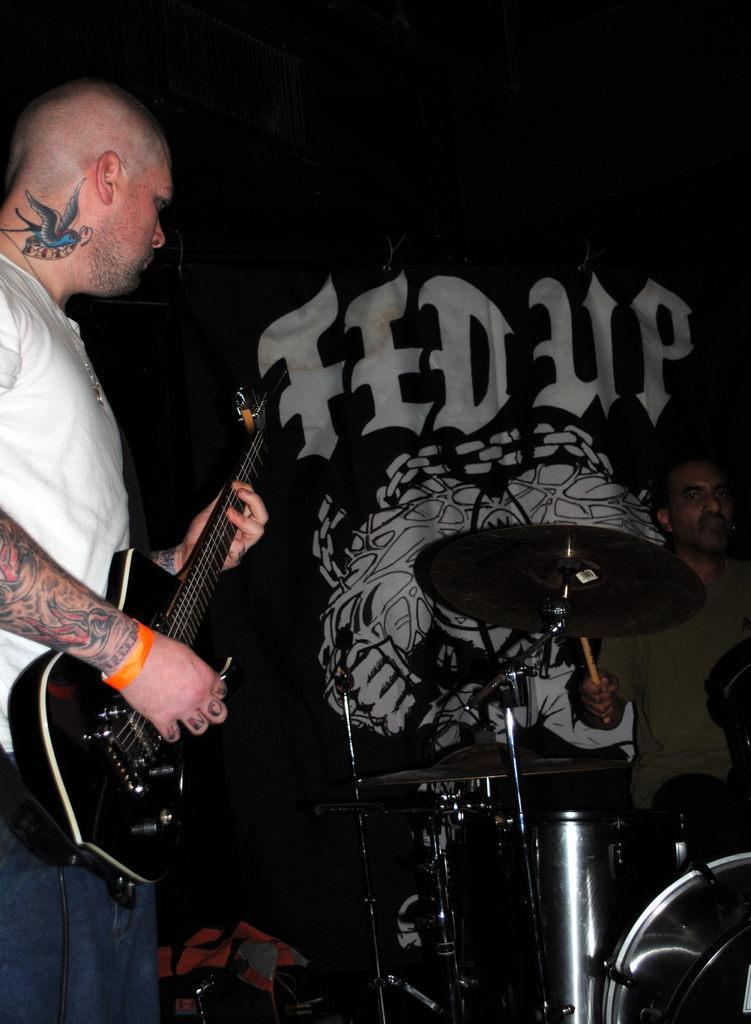Can you describe this image briefly? This man wore white t-shirt and playing guitar. This man is sitting and playing these musical instruments with stick. 